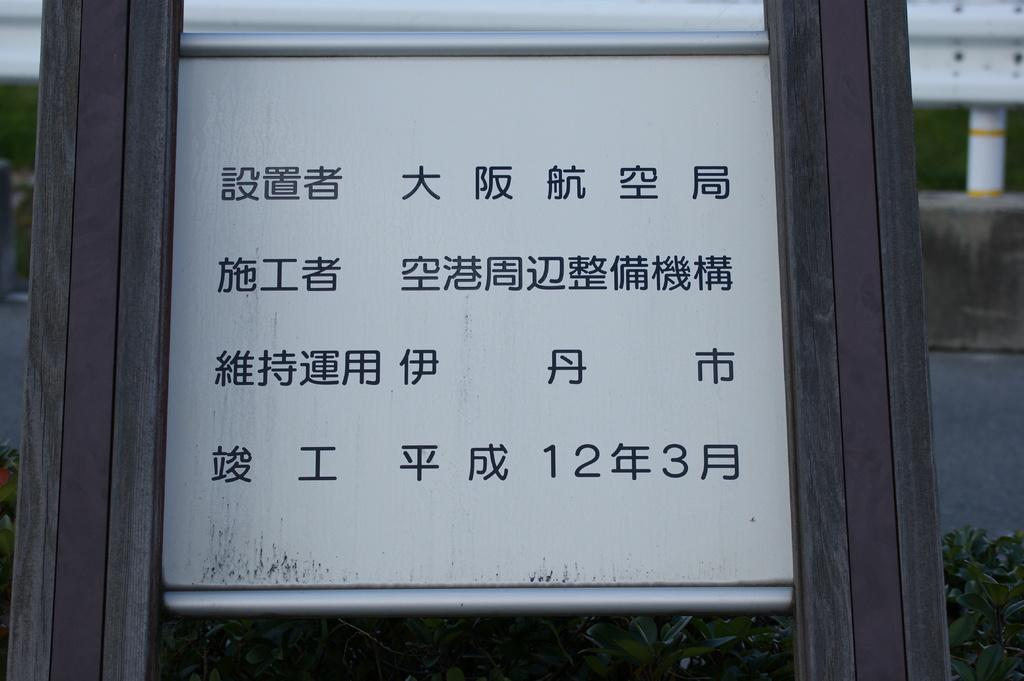What is the main object in the image? There is a white board in the image. What other objects can be seen in the image? There are two wooden poles in the image. What type of natural environment is visible in the image? Grass is visible in the image. What man-made structure can be seen in the image? There is a road in the image. How would you describe the overall clarity of the image? The background of the image is slightly blurred. What type of battle is taking place in the image? There is no battle present in the image; it features a white board, wooden poles, grass, a road, and a slightly blurred background. 